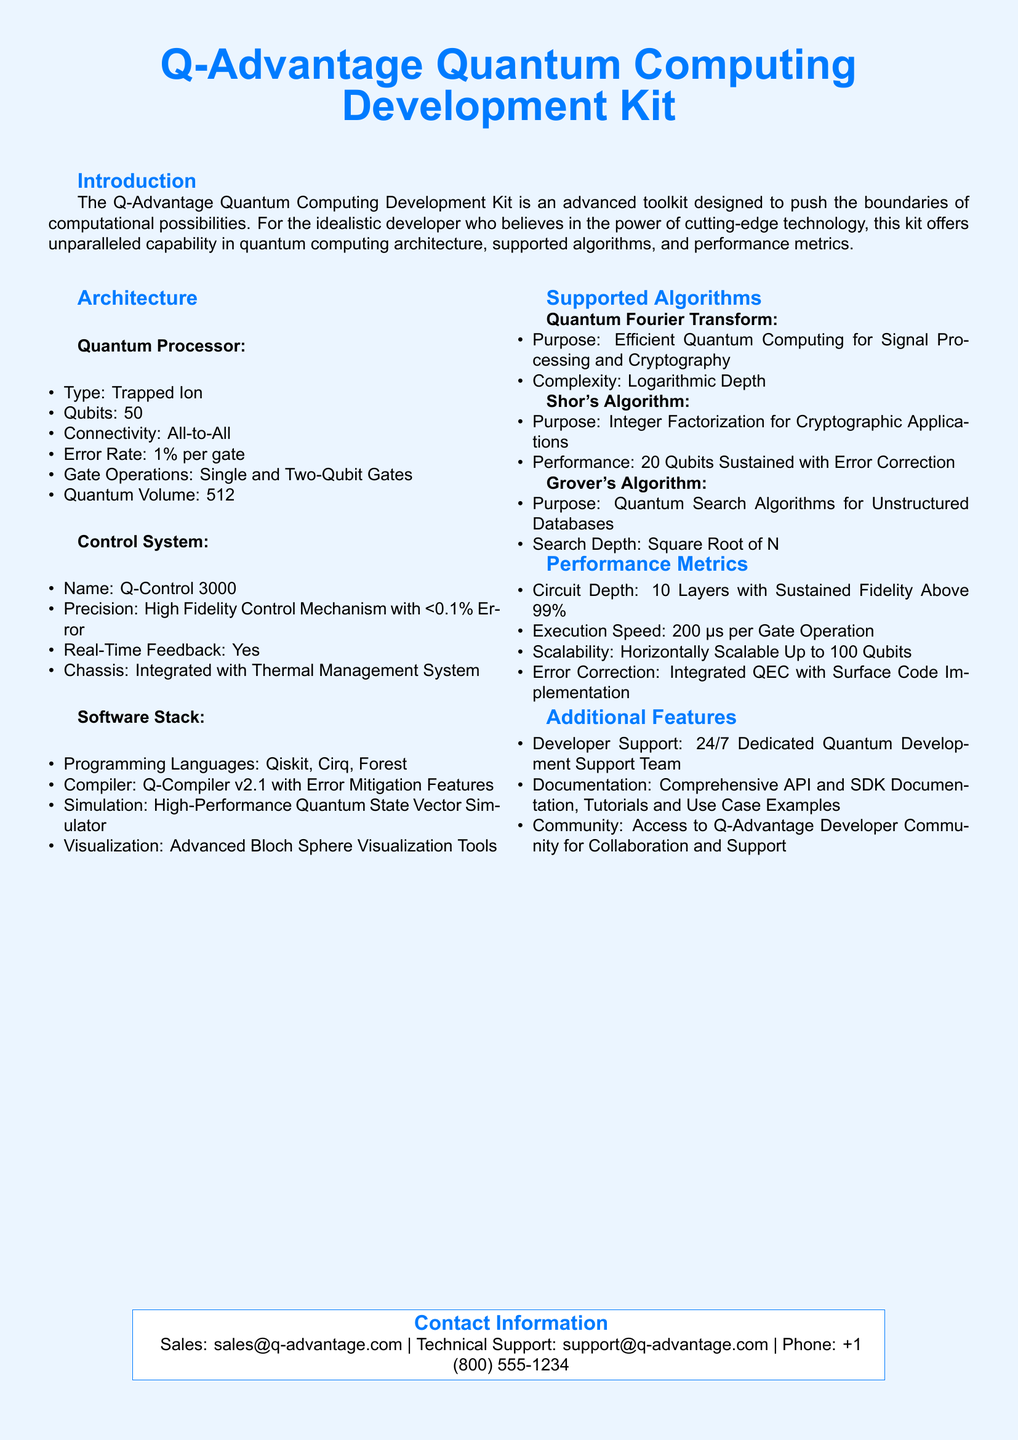What type of quantum processor is used? The document specifies that the type of quantum processor is "Trapped Ion."
Answer: Trapped Ion How many qubits does the quantum processor have? The document states that the quantum processor has "50" qubits.
Answer: 50 What is the error rate per gate? The document mentions that the error rate per gate is "1%."
Answer: 1% Which programming languages are supported? The document lists the supported programming languages as "Qiskit, Cirq, Forest."
Answer: Qiskit, Cirq, Forest What is the execution speed for gate operations? The document specifies that the execution speed is "200 μs per Gate Operation."
Answer: 200 μs Which algorithm is used for integer factorization? The document states that "Shor's Algorithm" is used for integer factorization.
Answer: Shor's Algorithm What is the circuit depth with sustained fidelity? The document indicates that the circuit depth is "10 Layers with Sustained Fidelity Above 99%."
Answer: 10 Layers with Sustained Fidelity Above 99% What is the name of the precision control system? The document specifies that the precision control system is called "Q-Control 3000."
Answer: Q-Control 3000 What additional feature supports developer collaboration? The document states there is access to the "Q-Advantage Developer Community for Collaboration and Support."
Answer: Q-Advantage Developer Community 